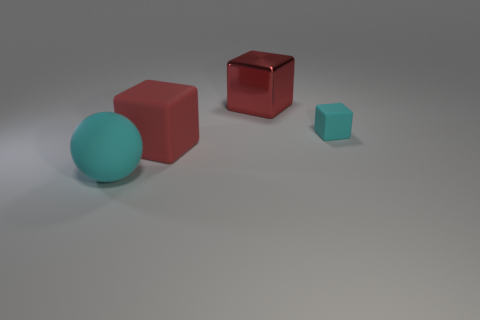Add 3 large matte objects. How many objects exist? 7 Subtract all balls. How many objects are left? 3 Add 3 red matte objects. How many red matte objects exist? 4 Subtract 2 red blocks. How many objects are left? 2 Subtract all large yellow shiny cylinders. Subtract all red blocks. How many objects are left? 2 Add 4 big red metal blocks. How many big red metal blocks are left? 5 